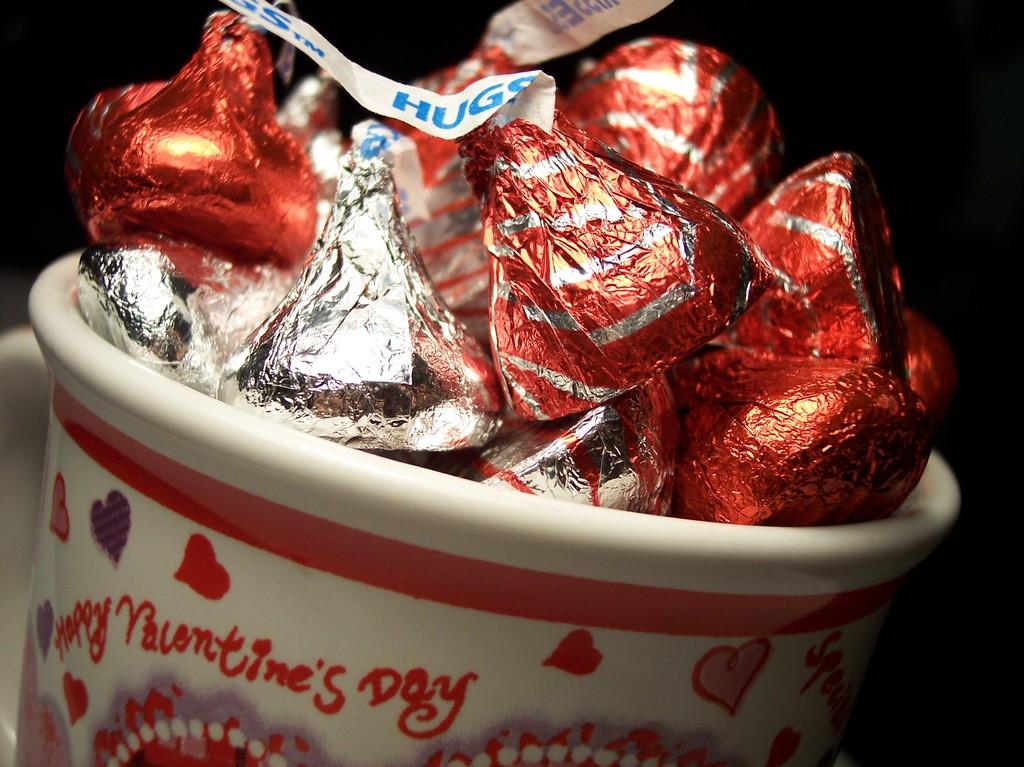What is in the cup that is visible in the image? The cup is filled with chocolates. What can be observed about the chocolates in the image? The chocolates have wrappers. How would you describe the background of the image? The background of the image appears dark. What type of friction can be seen between the brother and the chocolates in the image? There is no brother present in the image, and therefore no interaction or friction between a brother and the chocolates can be observed. 